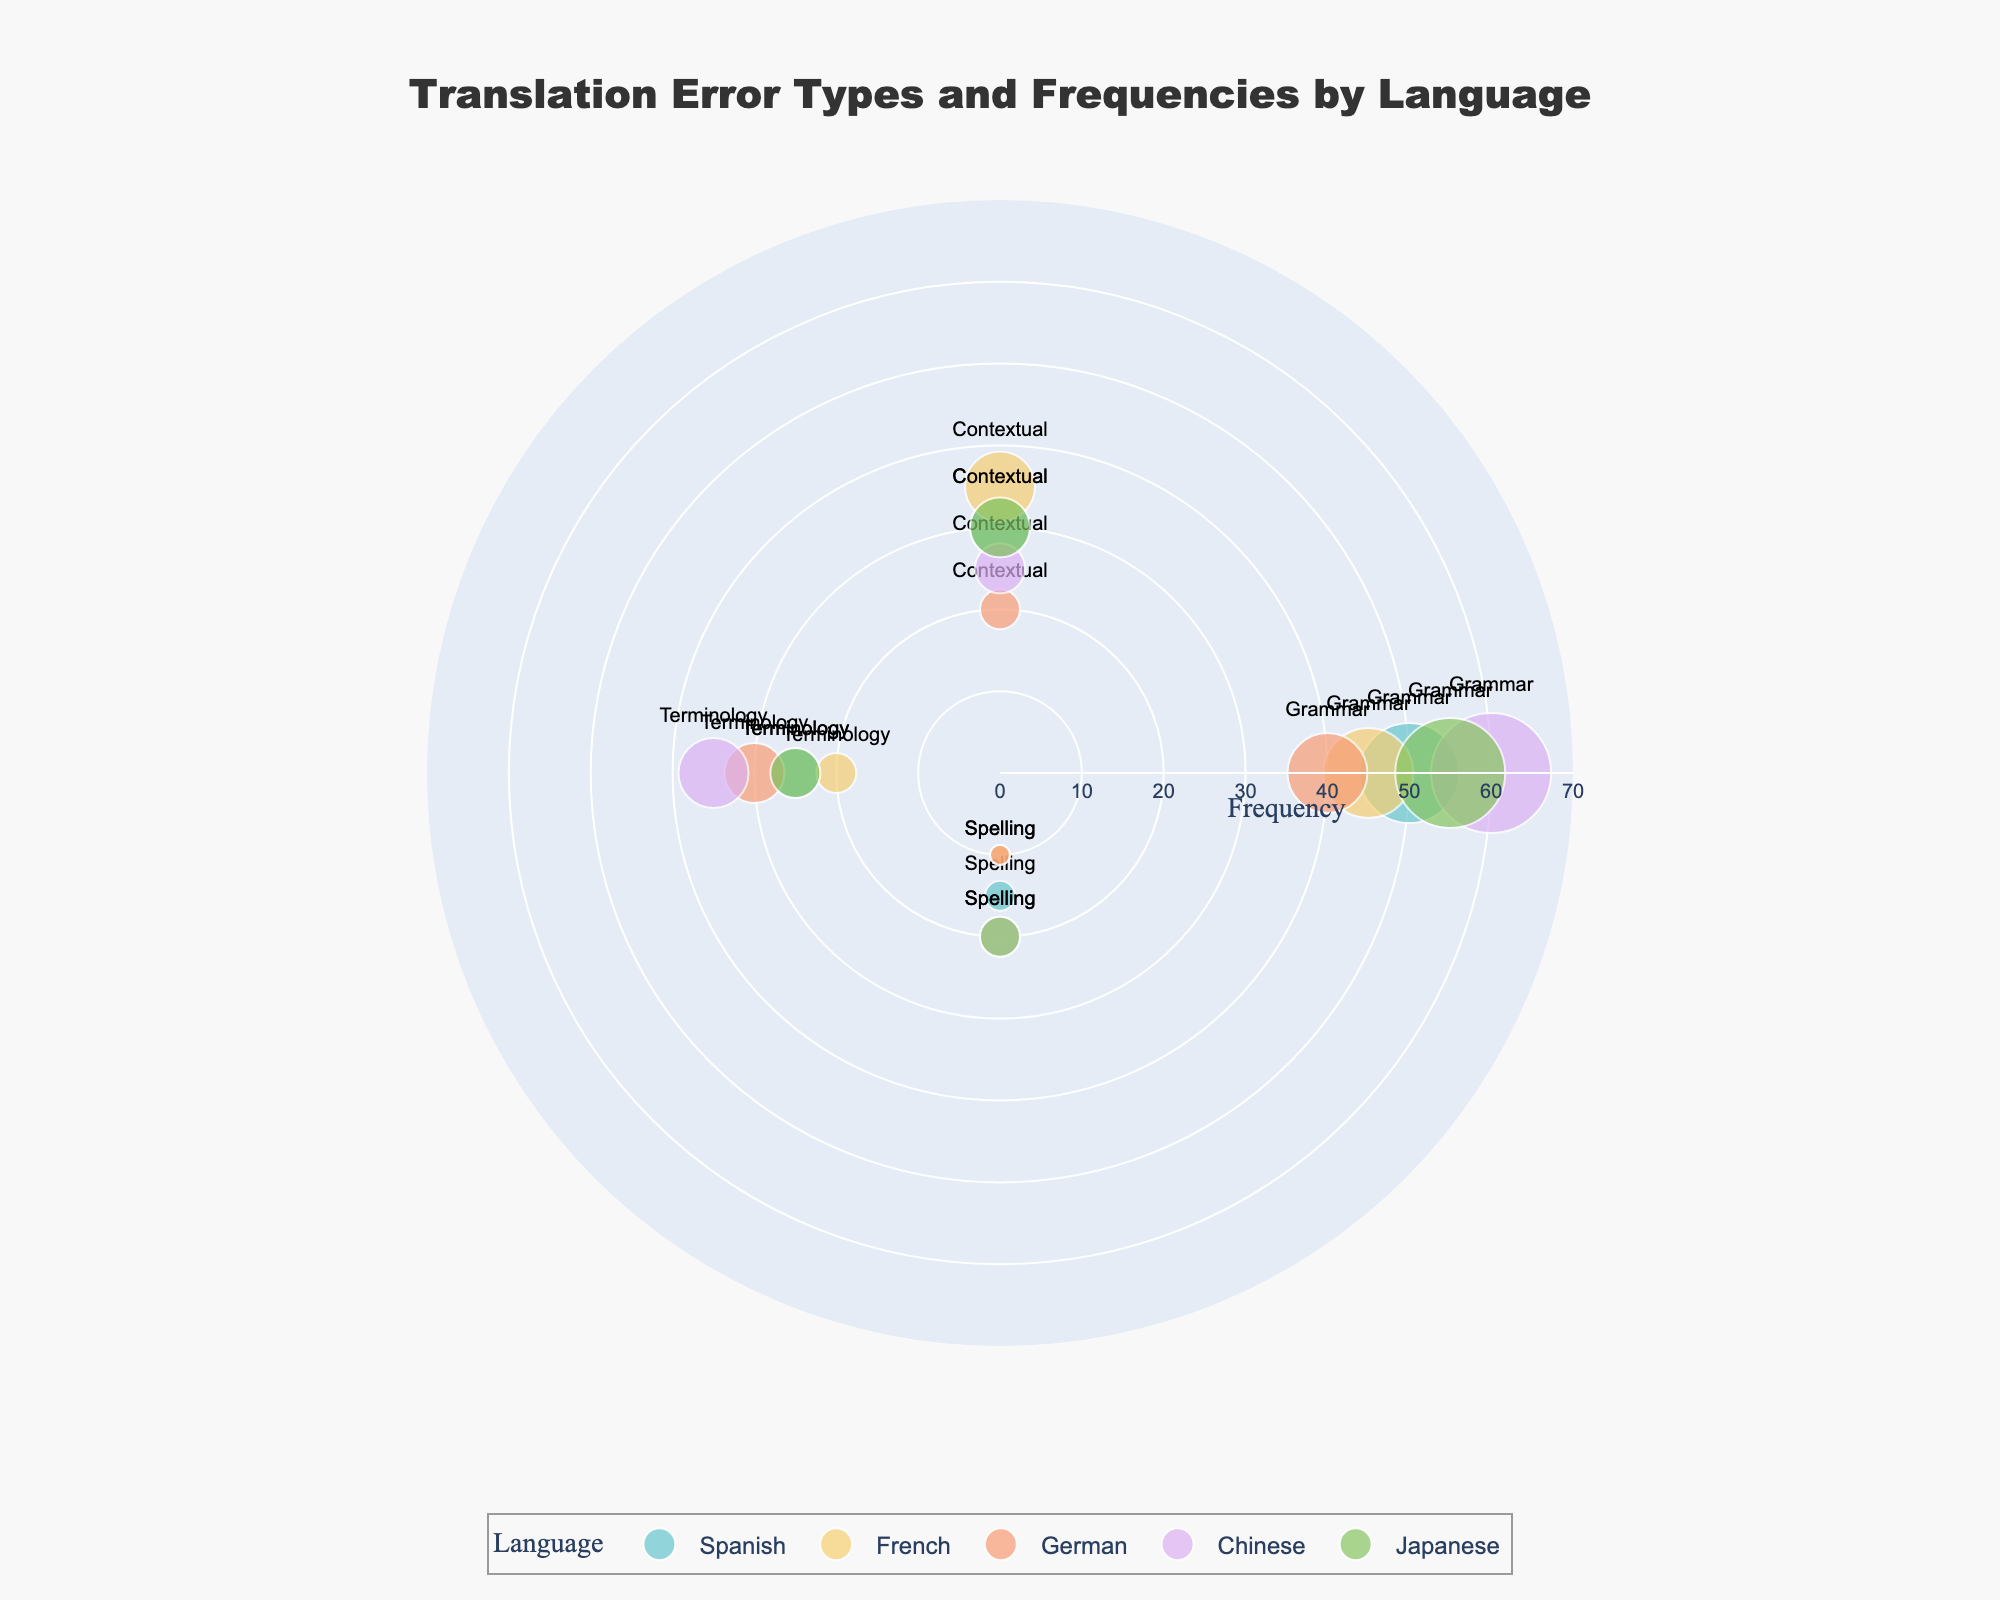What is the most common type of translation error in Chinese? The polar scatter chart shows that Grammar errors are the most frequent in Chinese with a frequency of 60.
Answer: Grammar Which language has the highest frequency of Contextual translation errors? By inspecting the scatter points labeled with "Contextual," French has the highest frequency with a frequency of 35.
Answer: French What is the combined frequency of Terminology errors for Spanish and German? Adding the frequencies for Terminology errors in Spanish (25) and German (30) results in a total frequency of 55.
Answer: 55 Which language has the least frequent Spelling errors? From the scatter points labeled "Spelling," both French and German have the lowest frequency, each with a frequency of 10.
Answer: French, German In which language are Grammar errors less frequent than in all others? The scatter points labeled "Grammar" show that German has the smallest value for Grammar errors at 40.
Answer: German Compare the frequency of Terminology errors between Chinese and Japanese. The scatter points labeled "Terminology" show that Chinese has a frequency of 35, which is higher than Japanese's frequency of 25.
Answer: Chinese What is the total frequency of Grammar errors across all languages? Adding the frequencies for Grammar errors: Spanish (50), French (45), German (40), Chinese (60), and Japanese (55) results in a total frequency of 250.
Answer: 250 Which error type has the closest frequency in Japanese and Spanish? Comparing the frequencies for each error type between Japanese and Spanish: Grammar (55 vs. 50), Contextual (30 vs. 30), Terminology (25 vs. 25), and Spelling (20 vs. 15). Contextual and Terminology errors have the closest frequencies.
Answer: Contextual, Terminology What is the average frequency of Spelling errors across all languages? Summing the Spelling error frequencies: Spanish (15), French (10), German (10), Chinese (20), and Japanese (20) gives a total of 75. The average is 75/5 = 15.
Answer: 15 